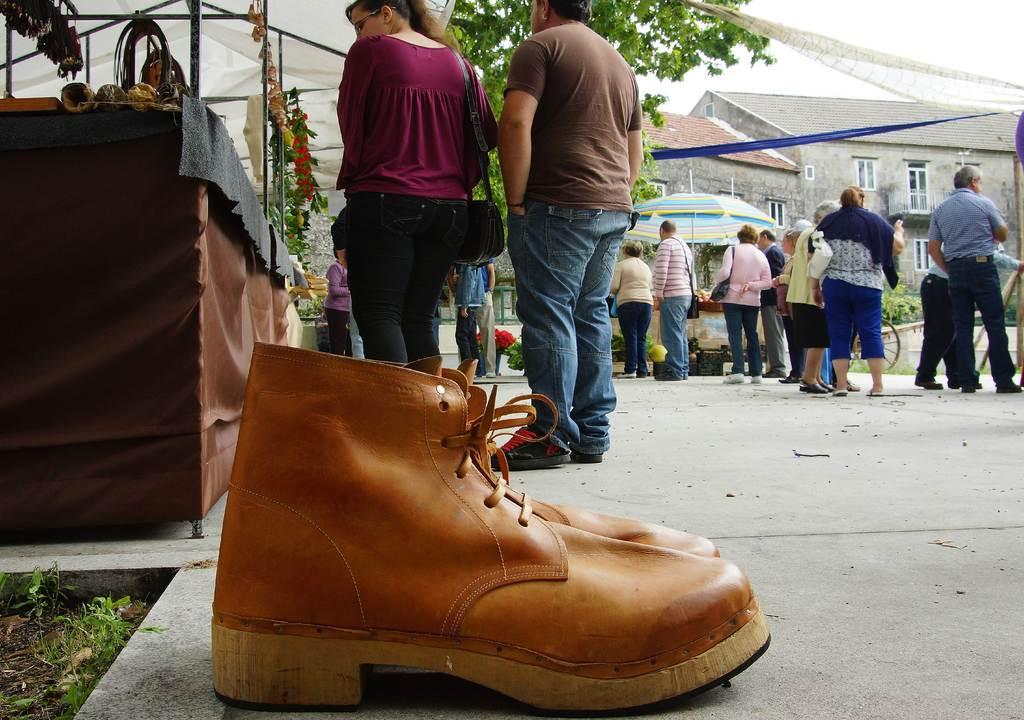What can be seen in the image involving people? There are people standing in the image. What type of structures are visible in the image? There are buildings visible in the image. What natural element is present in the image? There is a tree in the image. What type of footwear can be seen in the image? There are shoes in the image. What objects are being used for protection from the weather? There are umbrellas in the image. What type of establishment is present in the image? There is a store in the image. What accessory is the woman wearing in the image? The woman is wearing a handbag in the image. How would you describe the sky in the image? The sky is cloudy in the image. What type of crook can be seen in the image? There is no crook present in the image. How is the payment being processed in the image? There is no indication of a payment process in the image. 